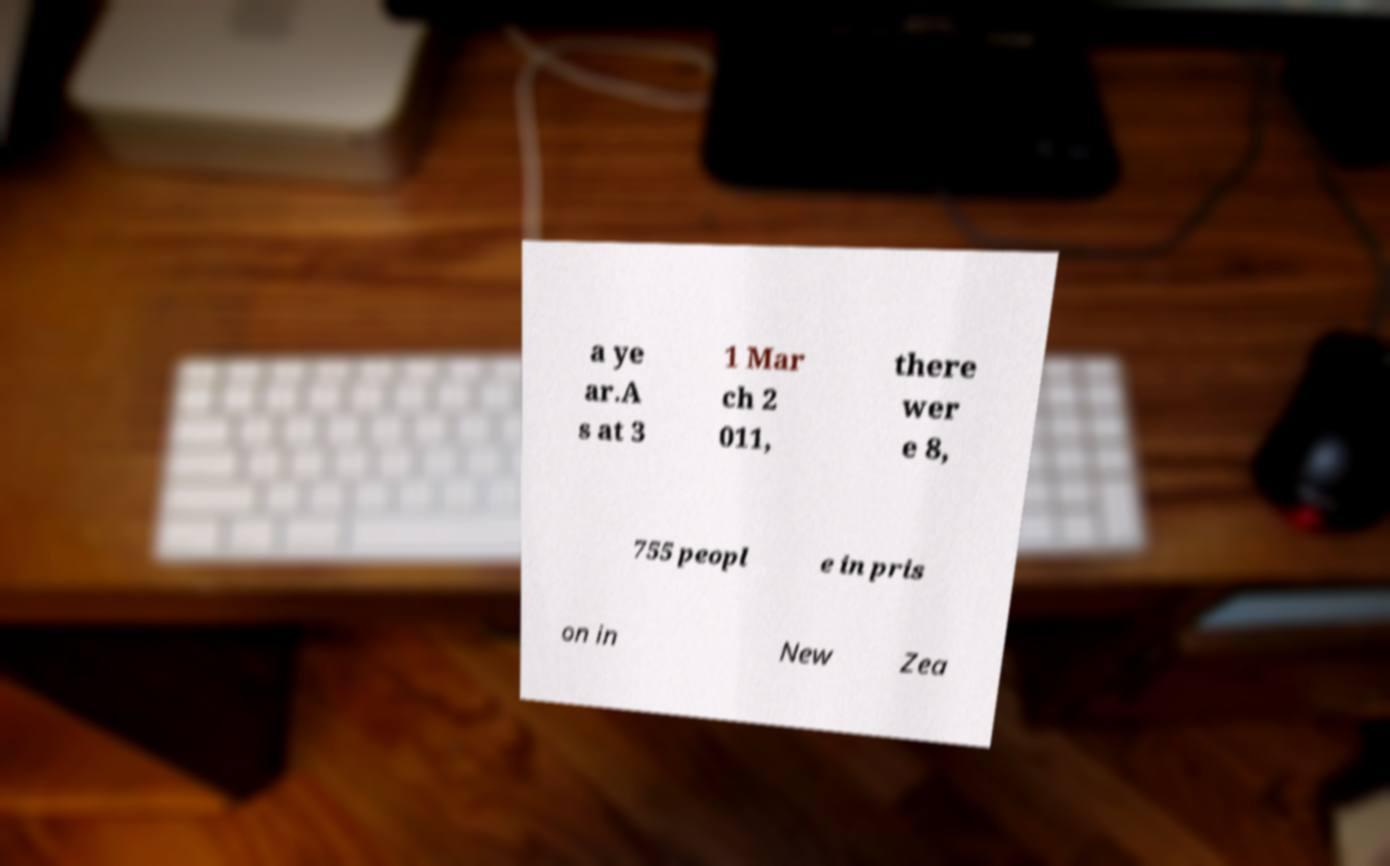There's text embedded in this image that I need extracted. Can you transcribe it verbatim? a ye ar.A s at 3 1 Mar ch 2 011, there wer e 8, 755 peopl e in pris on in New Zea 